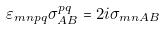<formula> <loc_0><loc_0><loc_500><loc_500>\varepsilon _ { m n p q } \sigma ^ { p q } _ { A B } = 2 i \sigma _ { m n A B }</formula> 